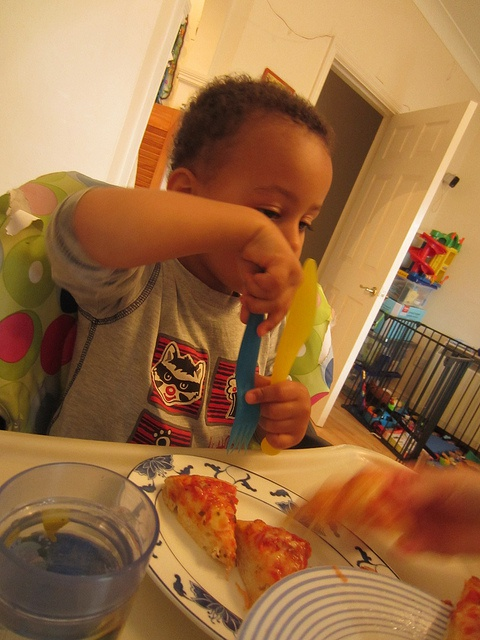Describe the objects in this image and their specific colors. I can see people in tan, maroon, brown, and black tones, cup in tan, maroon, olive, and black tones, chair in tan, olive, black, and maroon tones, people in tan, brown, maroon, and red tones, and pizza in tan, brown, red, and maroon tones in this image. 